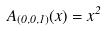Convert formula to latex. <formula><loc_0><loc_0><loc_500><loc_500>A _ { ( 0 , 0 , 1 ) } ( x ) = x ^ { 2 }</formula> 